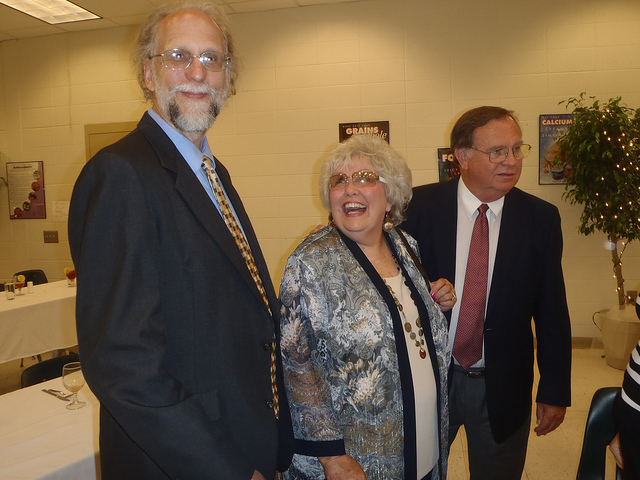<image>What machine is on the desk? It is unknown what machine is on the desk. It can be a computer or a telephone. Which outfit matches better? It's ambiguous to determine which outfit matches better without a picture. What machine is on the desk? There is no machine on the desk in the image. Which outfit matches better? I am not sure which outfit matches better. It can be seen that the man on the left or the one on the far right outfit might be better. 